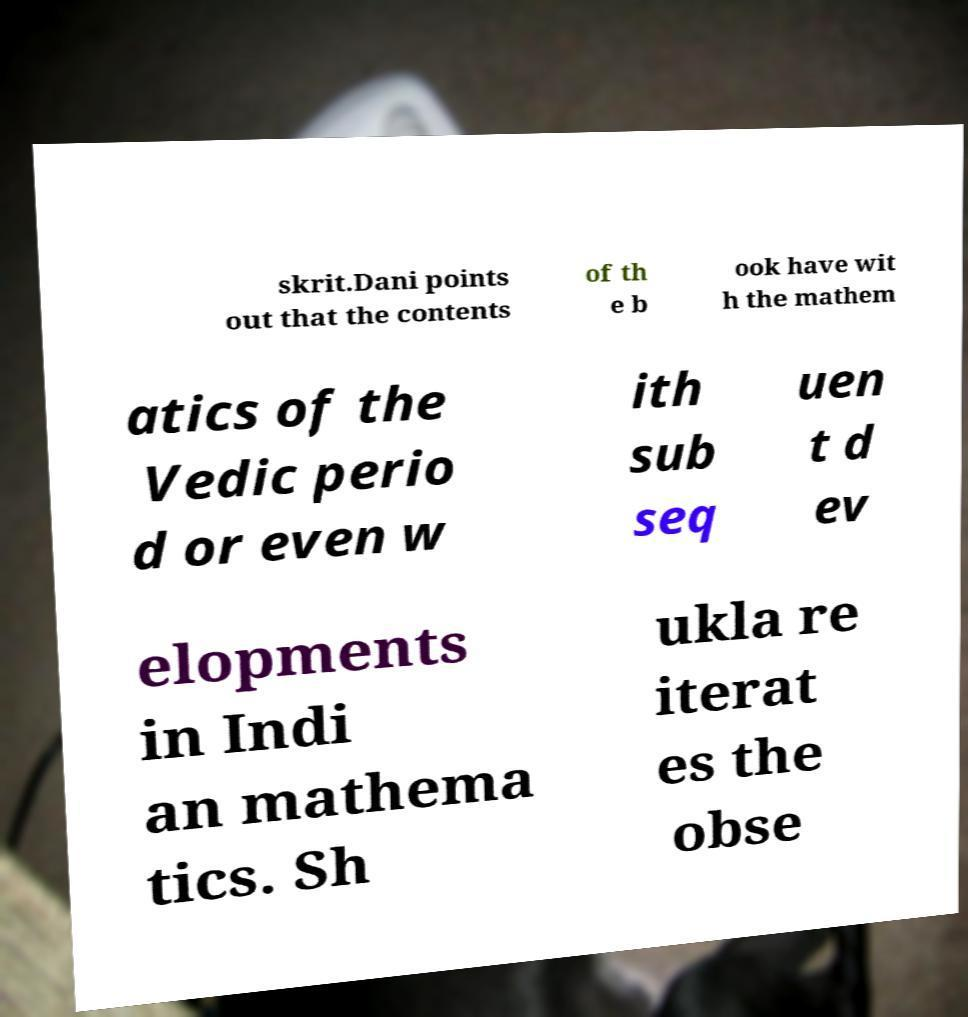Could you extract and type out the text from this image? skrit.Dani points out that the contents of th e b ook have wit h the mathem atics of the Vedic perio d or even w ith sub seq uen t d ev elopments in Indi an mathema tics. Sh ukla re iterat es the obse 